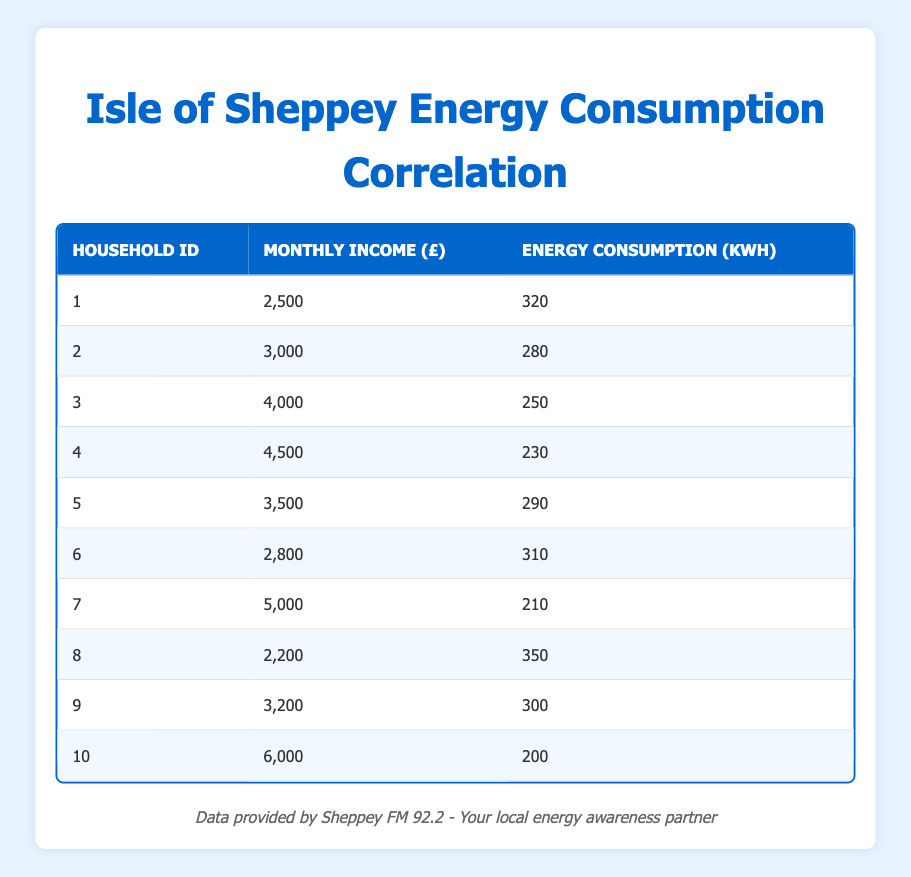What is the energy consumption of the household with a monthly income of £4000? The table shows that for Household ID 3, which has a monthly income of £4000, the energy consumption is 250 kWh.
Answer: 250 kWh How many households have an energy consumption greater than 300 kWh? By looking at the Energy Consumption column, the households with energy consumption greater than 300 kWh are Household IDs 1, 6, and 8. This gives us a total of 3 households.
Answer: 3 What is the difference in energy consumption between the household with the highest and lowest income? The household with the highest income is Household ID 10 (income of £6000) with energy consumption of 200 kWh, and the lowest income household is Household ID 8 (income of £2200) with energy consumption of 350 kWh. The difference is 350 - 200 = 150 kWh.
Answer: 150 kWh Is there a household with a monthly income of £4500 that has energy consumption less than 250 kWh? Yes, Household ID 4 has a monthly income of £4500 and its energy consumption is 230 kWh, which is less than 250 kWh.
Answer: Yes What is the average monthly income of the households in the table? The total monthly income from the table is 2500 + 3000 + 4000 + 4500 + 3500 + 2800 + 5000 + 2200 + 3200 + 6000 = 37,700. Since there are 10 households, the average income is 37,700 / 10 = 3770.
Answer: £3770 